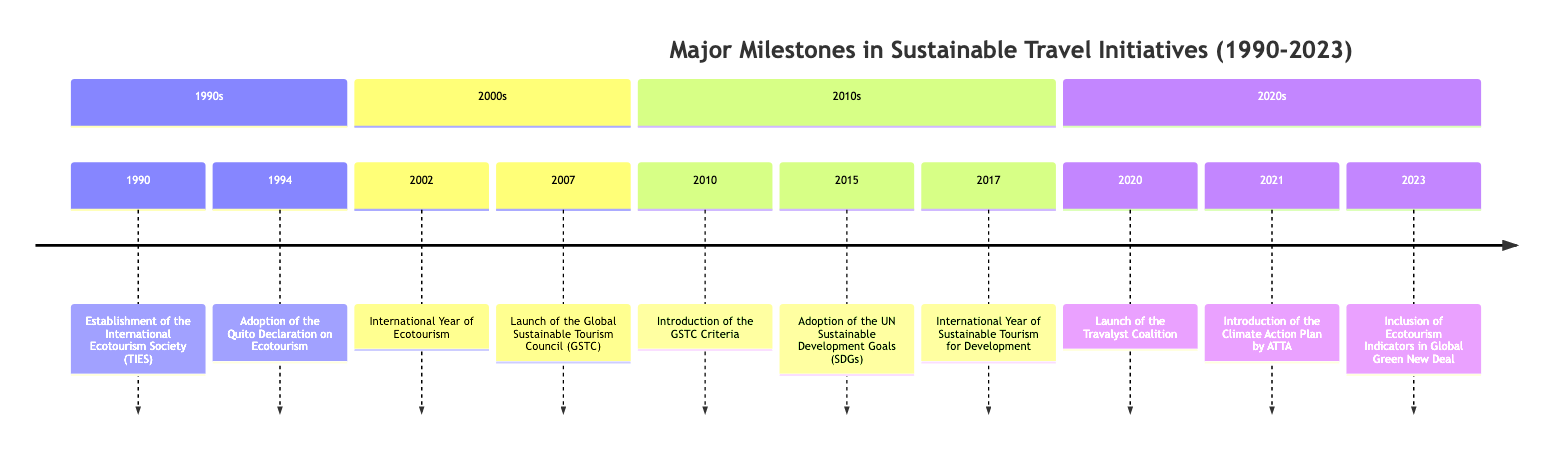What year was the International Ecotourism Society established? The diagram lists the event "Establishment of the International Ecotourism Society (TIES)" under the year 1990. Thus, by directly looking at the event associated with its corresponding year, we find that it was established in 1990.
Answer: 1990 How many major milestones are listed in the timeline? The timeline consists of 10 entries, with each entry representing a major milestone in sustainable travel initiatives from 1990 to 2023. Counting each entry in the timeline gives us the total number.
Answer: 10 What event occurred in 2015? Referring to the timeline under the 2010s section, we see the event "Adoption of the UN Sustainable Development Goals (SDGs)" listed for the year 2015. This is how we can pinpoint the specific event associated with that year.
Answer: Adoption of the UN Sustainable Development Goals (SDGs) Which organization launched the Climate Action Plan in 2021? The timeline details that "Introduction of the Climate Action Plan by the Adventure Travel Trade Association (ATTA)" occurred in 2021. This points to the Adventure Travel Trade Association (ATTA) as the organization responsible for launching the plan in that year.
Answer: Adventure Travel Trade Association (ATTA) What is the significance of 2002 in the timeline? In the year 2002, the event "International Year of Ecotourism" is marked on the timeline. This signifies a particular designation by the United Nations to emphasize the importance of ecotourism, thus making 2002 significant in the context of sustainable travel initiatives.
Answer: International Year of Ecotourism What initiative was launched by Prince Harry in 2020? The timeline includes the event "Launch of the Travalyst Coalition" listed for 2020. This indicates that this particular initiative, which promotes sustainable practices in travel, was launched by Prince Harry, hence identifying it as an important event for that year.
Answer: Launch of the Travalyst Coalition In which decade was the Global Sustainable Tourism Council (GSTC) launched? The timeline indicates that the GSTC was launched in 2007, which falls under the 2000s section of the timeline. This helps us identify the specific decade during which the Global Sustainable Tourism Council was created.
Answer: 2000s What milestone relates to the fight against climate change in 2023? The event "Inclusion of Ecotourism Indicators in Global Green New Deal" is noted for 2023, indicating its relevance to the broader efforts aimed at combating climate change. This links the milestone directly to environmental sustainability initiatives in that year.
Answer: Inclusion of Ecotourism Indicators in Global Green New Deal How many events emphasize international years related to sustainable tourism? The timeline highlights two events that pertain to international year designations: "International Year of Ecotourism" in 2002 and "International Year of Sustainable Tourism for Development" in 2017. Counting these gives us the answer.
Answer: 2 What major milestone took place between 2010 and 2015? The timeline includes the milestone "Adoption of the UN Sustainable Development Goals (SDGs)" that occurred in 2015 and "Introduction of the GSTC Criteria" that took place in 2010. Both events within this range contribute significantly to sustainable tourism initiatives.
Answer: Adoption of the UN Sustainable Development Goals (SDGs) and Introduction of the GSTC Criteria 